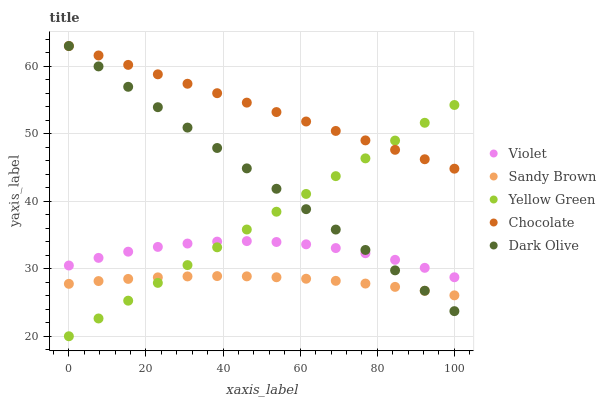Does Sandy Brown have the minimum area under the curve?
Answer yes or no. Yes. Does Chocolate have the maximum area under the curve?
Answer yes or no. Yes. Does Chocolate have the minimum area under the curve?
Answer yes or no. No. Does Sandy Brown have the maximum area under the curve?
Answer yes or no. No. Is Yellow Green the smoothest?
Answer yes or no. Yes. Is Violet the roughest?
Answer yes or no. Yes. Is Chocolate the smoothest?
Answer yes or no. No. Is Chocolate the roughest?
Answer yes or no. No. Does Yellow Green have the lowest value?
Answer yes or no. Yes. Does Sandy Brown have the lowest value?
Answer yes or no. No. Does Chocolate have the highest value?
Answer yes or no. Yes. Does Sandy Brown have the highest value?
Answer yes or no. No. Is Violet less than Chocolate?
Answer yes or no. Yes. Is Chocolate greater than Sandy Brown?
Answer yes or no. Yes. Does Chocolate intersect Dark Olive?
Answer yes or no. Yes. Is Chocolate less than Dark Olive?
Answer yes or no. No. Is Chocolate greater than Dark Olive?
Answer yes or no. No. Does Violet intersect Chocolate?
Answer yes or no. No. 